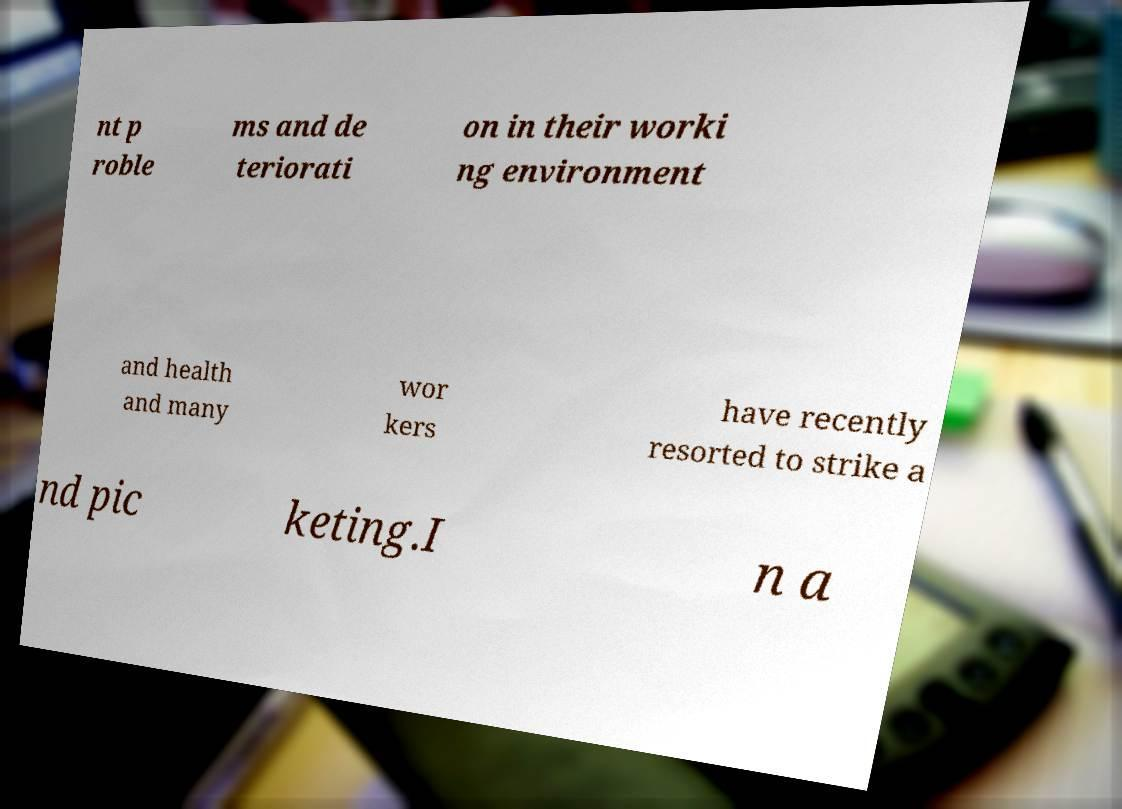Please identify and transcribe the text found in this image. nt p roble ms and de teriorati on in their worki ng environment and health and many wor kers have recently resorted to strike a nd pic keting.I n a 